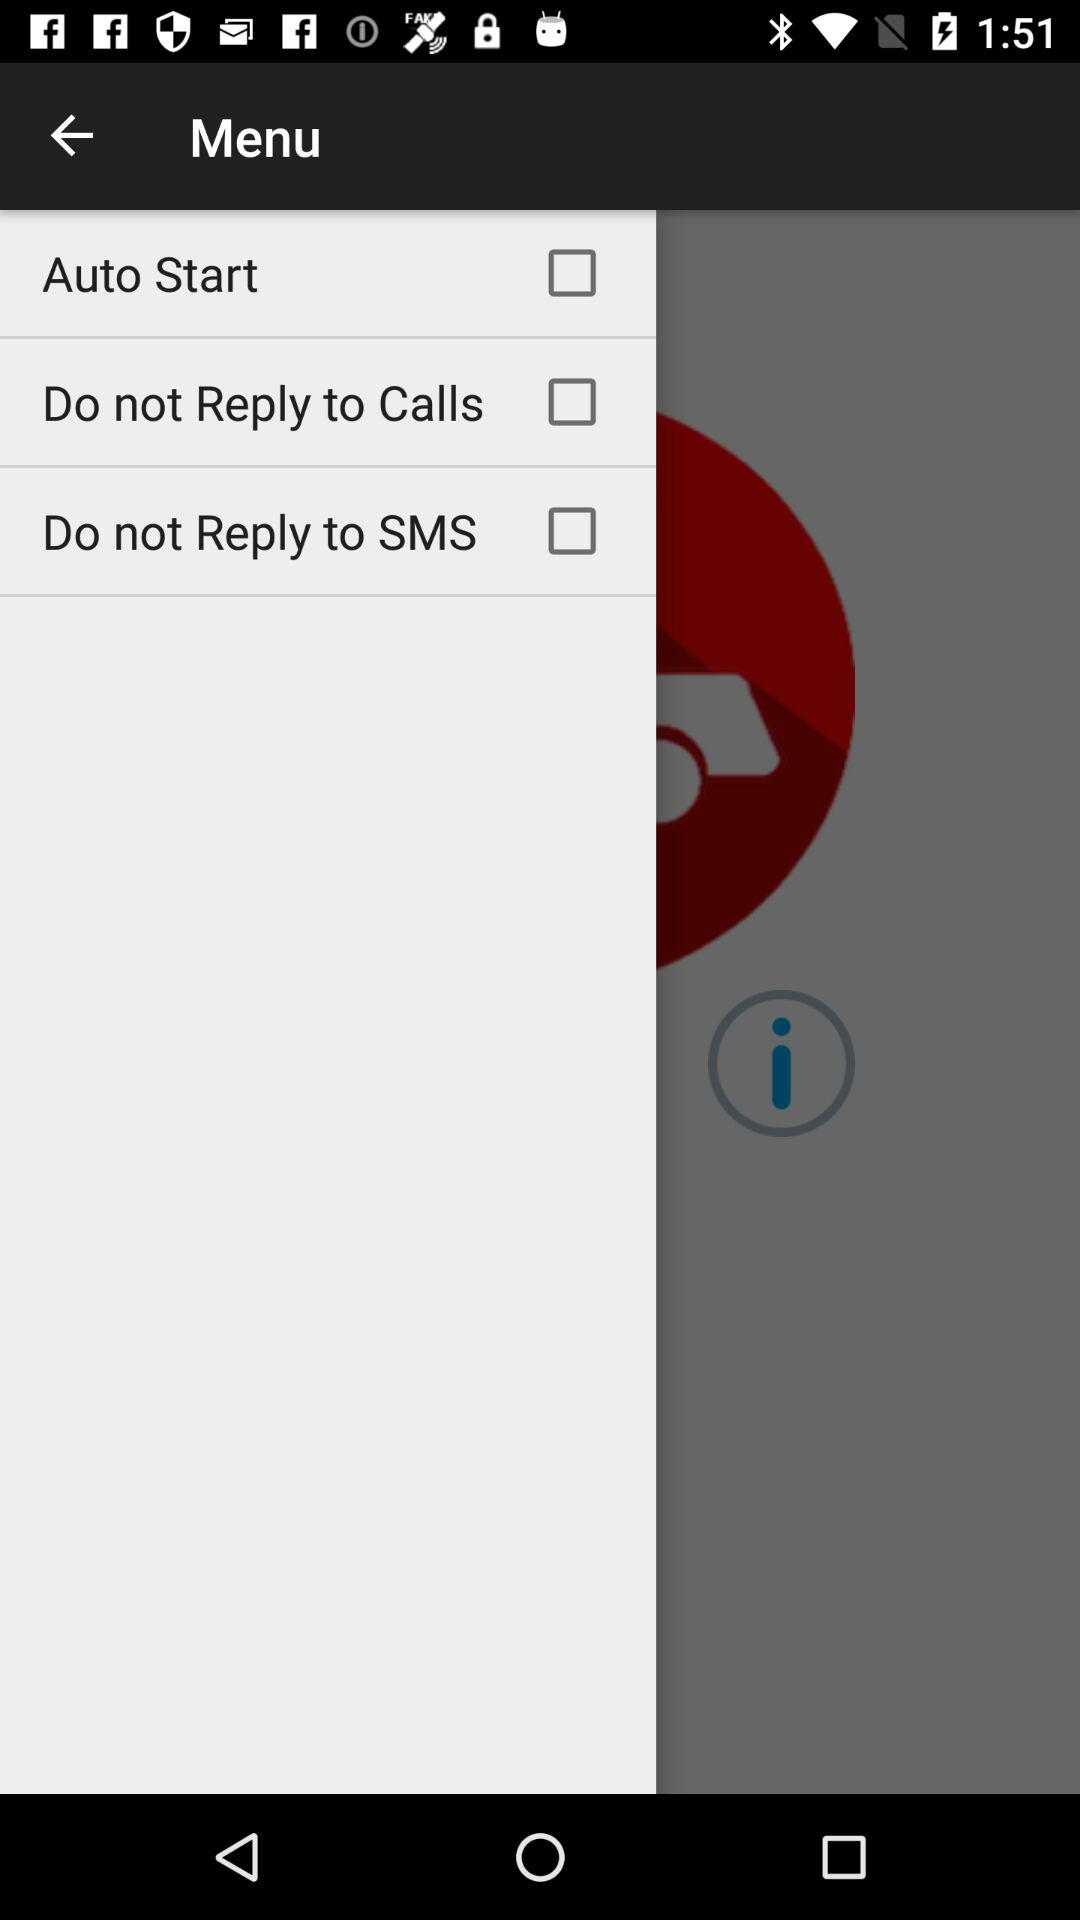What is the current status of the "Do not Reply to Calls? The current status is "off". 